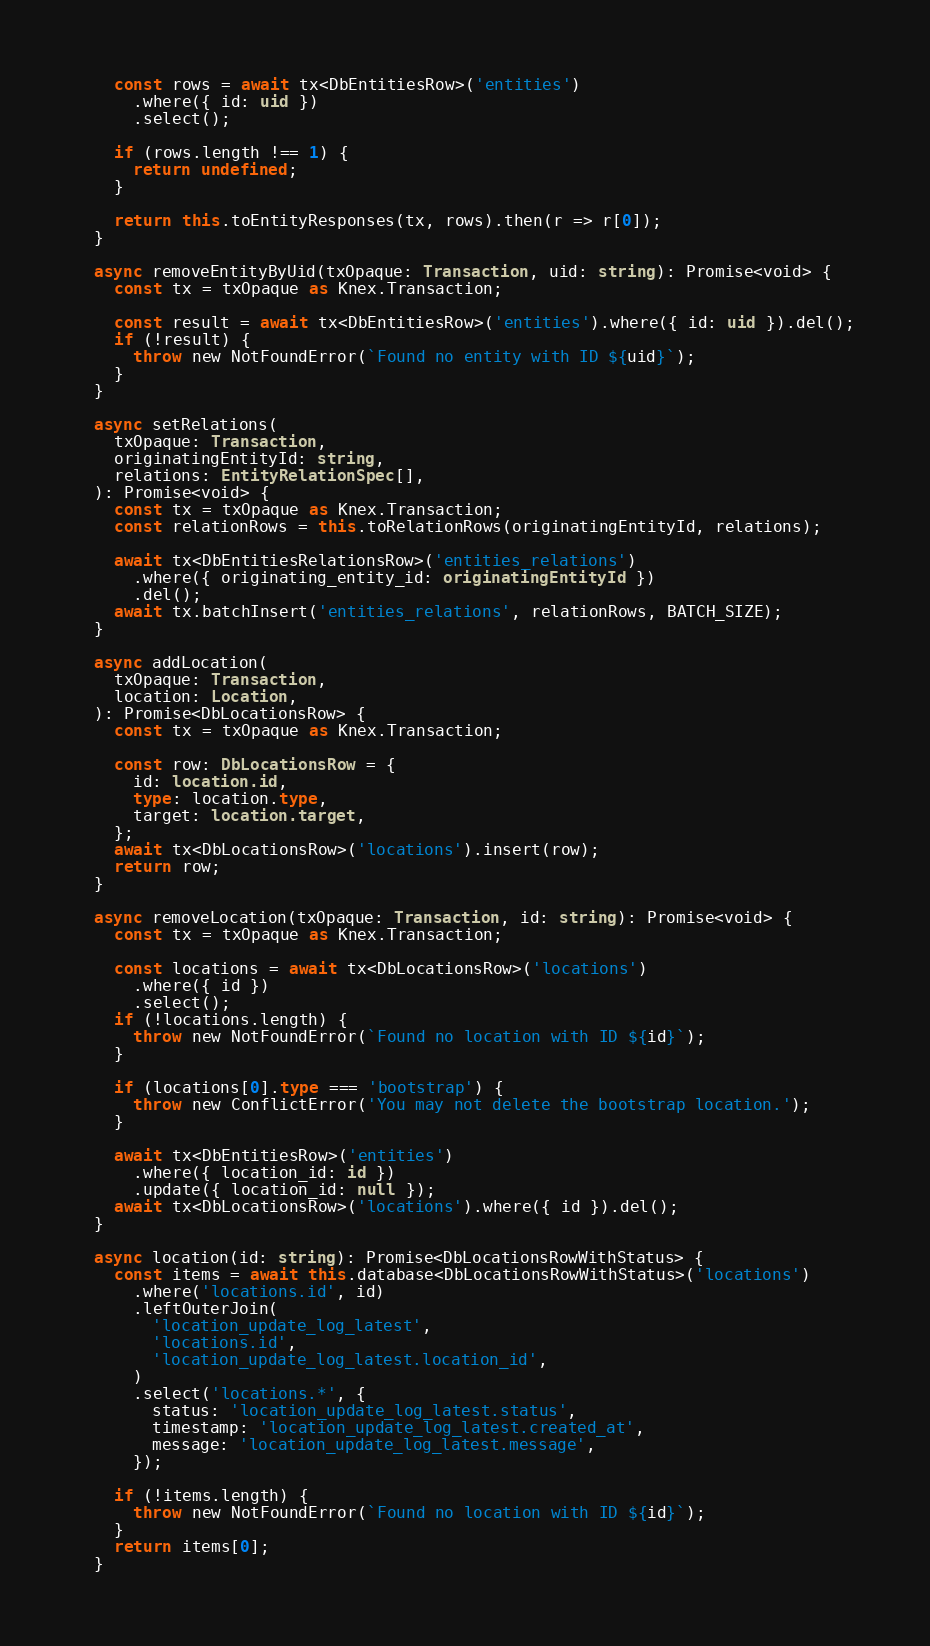<code> <loc_0><loc_0><loc_500><loc_500><_TypeScript_>
    const rows = await tx<DbEntitiesRow>('entities')
      .where({ id: uid })
      .select();

    if (rows.length !== 1) {
      return undefined;
    }

    return this.toEntityResponses(tx, rows).then(r => r[0]);
  }

  async removeEntityByUid(txOpaque: Transaction, uid: string): Promise<void> {
    const tx = txOpaque as Knex.Transaction;

    const result = await tx<DbEntitiesRow>('entities').where({ id: uid }).del();
    if (!result) {
      throw new NotFoundError(`Found no entity with ID ${uid}`);
    }
  }

  async setRelations(
    txOpaque: Transaction,
    originatingEntityId: string,
    relations: EntityRelationSpec[],
  ): Promise<void> {
    const tx = txOpaque as Knex.Transaction;
    const relationRows = this.toRelationRows(originatingEntityId, relations);

    await tx<DbEntitiesRelationsRow>('entities_relations')
      .where({ originating_entity_id: originatingEntityId })
      .del();
    await tx.batchInsert('entities_relations', relationRows, BATCH_SIZE);
  }

  async addLocation(
    txOpaque: Transaction,
    location: Location,
  ): Promise<DbLocationsRow> {
    const tx = txOpaque as Knex.Transaction;

    const row: DbLocationsRow = {
      id: location.id,
      type: location.type,
      target: location.target,
    };
    await tx<DbLocationsRow>('locations').insert(row);
    return row;
  }

  async removeLocation(txOpaque: Transaction, id: string): Promise<void> {
    const tx = txOpaque as Knex.Transaction;

    const locations = await tx<DbLocationsRow>('locations')
      .where({ id })
      .select();
    if (!locations.length) {
      throw new NotFoundError(`Found no location with ID ${id}`);
    }

    if (locations[0].type === 'bootstrap') {
      throw new ConflictError('You may not delete the bootstrap location.');
    }

    await tx<DbEntitiesRow>('entities')
      .where({ location_id: id })
      .update({ location_id: null });
    await tx<DbLocationsRow>('locations').where({ id }).del();
  }

  async location(id: string): Promise<DbLocationsRowWithStatus> {
    const items = await this.database<DbLocationsRowWithStatus>('locations')
      .where('locations.id', id)
      .leftOuterJoin(
        'location_update_log_latest',
        'locations.id',
        'location_update_log_latest.location_id',
      )
      .select('locations.*', {
        status: 'location_update_log_latest.status',
        timestamp: 'location_update_log_latest.created_at',
        message: 'location_update_log_latest.message',
      });

    if (!items.length) {
      throw new NotFoundError(`Found no location with ID ${id}`);
    }
    return items[0];
  }
</code> 